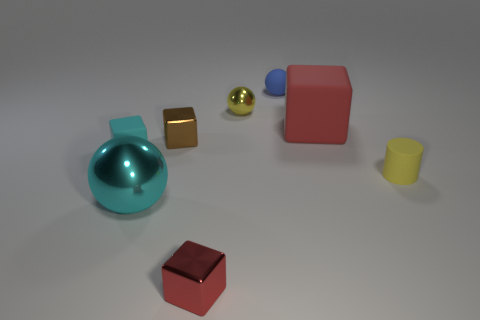Subtract all small spheres. How many spheres are left? 1 Add 1 tiny cubes. How many objects exist? 9 Subtract all red cubes. How many cubes are left? 2 Subtract all brown balls. How many yellow cubes are left? 0 Subtract 0 brown cylinders. How many objects are left? 8 Subtract all balls. How many objects are left? 5 Subtract all yellow balls. Subtract all red blocks. How many balls are left? 2 Subtract all small blue things. Subtract all tiny matte spheres. How many objects are left? 6 Add 7 blue spheres. How many blue spheres are left? 8 Add 1 yellow things. How many yellow things exist? 3 